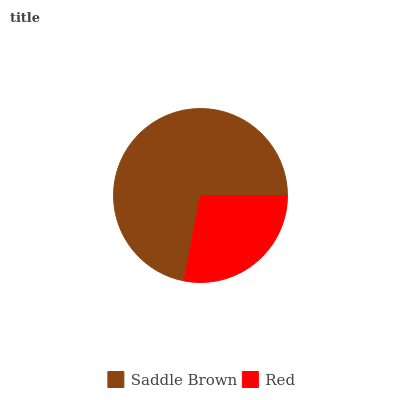Is Red the minimum?
Answer yes or no. Yes. Is Saddle Brown the maximum?
Answer yes or no. Yes. Is Red the maximum?
Answer yes or no. No. Is Saddle Brown greater than Red?
Answer yes or no. Yes. Is Red less than Saddle Brown?
Answer yes or no. Yes. Is Red greater than Saddle Brown?
Answer yes or no. No. Is Saddle Brown less than Red?
Answer yes or no. No. Is Saddle Brown the high median?
Answer yes or no. Yes. Is Red the low median?
Answer yes or no. Yes. Is Red the high median?
Answer yes or no. No. Is Saddle Brown the low median?
Answer yes or no. No. 